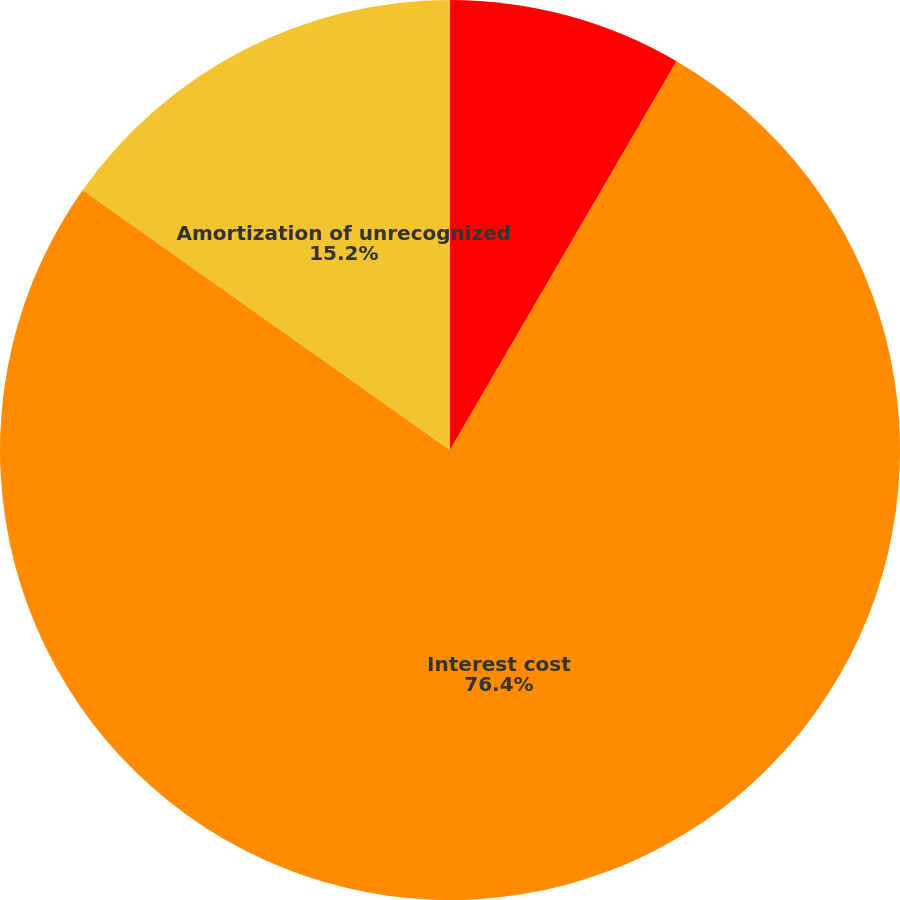<chart> <loc_0><loc_0><loc_500><loc_500><pie_chart><fcel>Service cost<fcel>Interest cost<fcel>Amortization of unrecognized<nl><fcel>8.4%<fcel>76.41%<fcel>15.2%<nl></chart> 